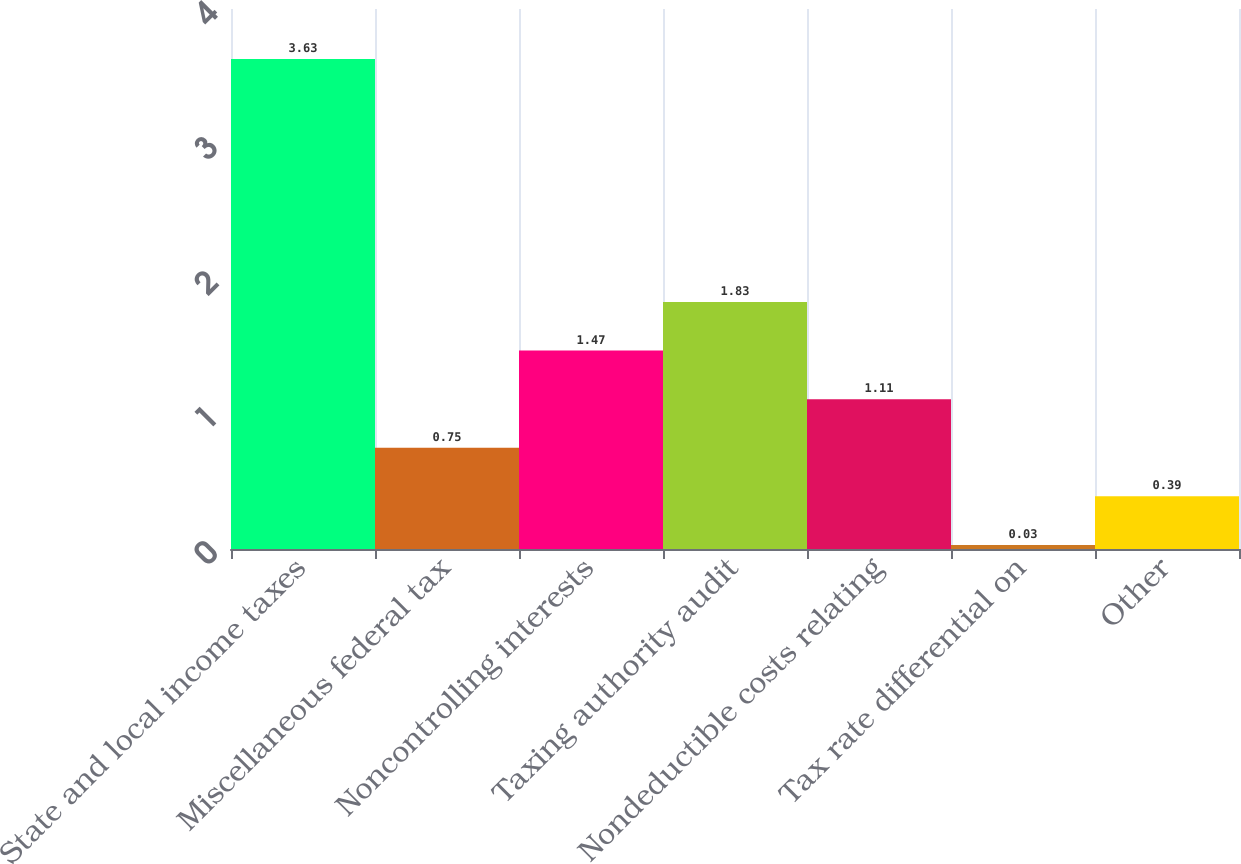Convert chart. <chart><loc_0><loc_0><loc_500><loc_500><bar_chart><fcel>State and local income taxes<fcel>Miscellaneous federal tax<fcel>Noncontrolling interests<fcel>Taxing authority audit<fcel>Nondeductible costs relating<fcel>Tax rate differential on<fcel>Other<nl><fcel>3.63<fcel>0.75<fcel>1.47<fcel>1.83<fcel>1.11<fcel>0.03<fcel>0.39<nl></chart> 